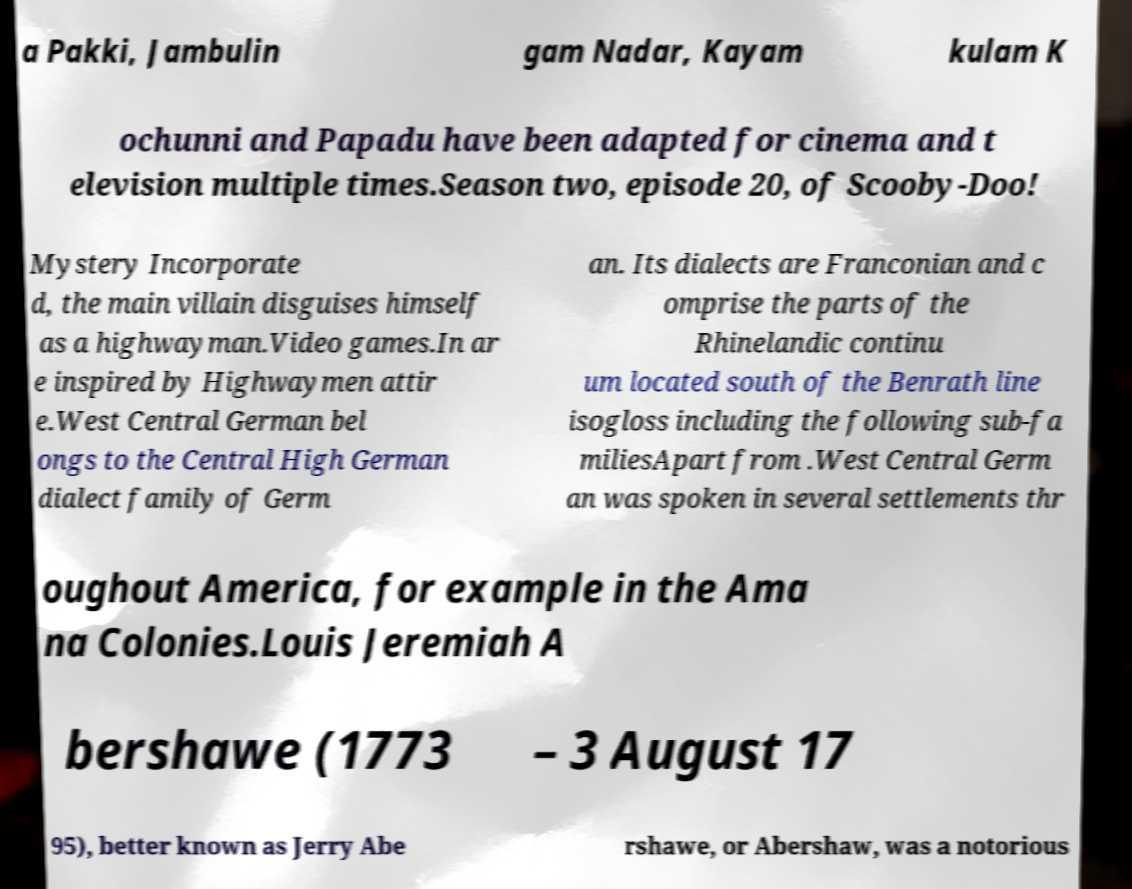I need the written content from this picture converted into text. Can you do that? a Pakki, Jambulin gam Nadar, Kayam kulam K ochunni and Papadu have been adapted for cinema and t elevision multiple times.Season two, episode 20, of Scooby-Doo! Mystery Incorporate d, the main villain disguises himself as a highwayman.Video games.In ar e inspired by Highwaymen attir e.West Central German bel ongs to the Central High German dialect family of Germ an. Its dialects are Franconian and c omprise the parts of the Rhinelandic continu um located south of the Benrath line isogloss including the following sub-fa miliesApart from .West Central Germ an was spoken in several settlements thr oughout America, for example in the Ama na Colonies.Louis Jeremiah A bershawe (1773 – 3 August 17 95), better known as Jerry Abe rshawe, or Abershaw, was a notorious 